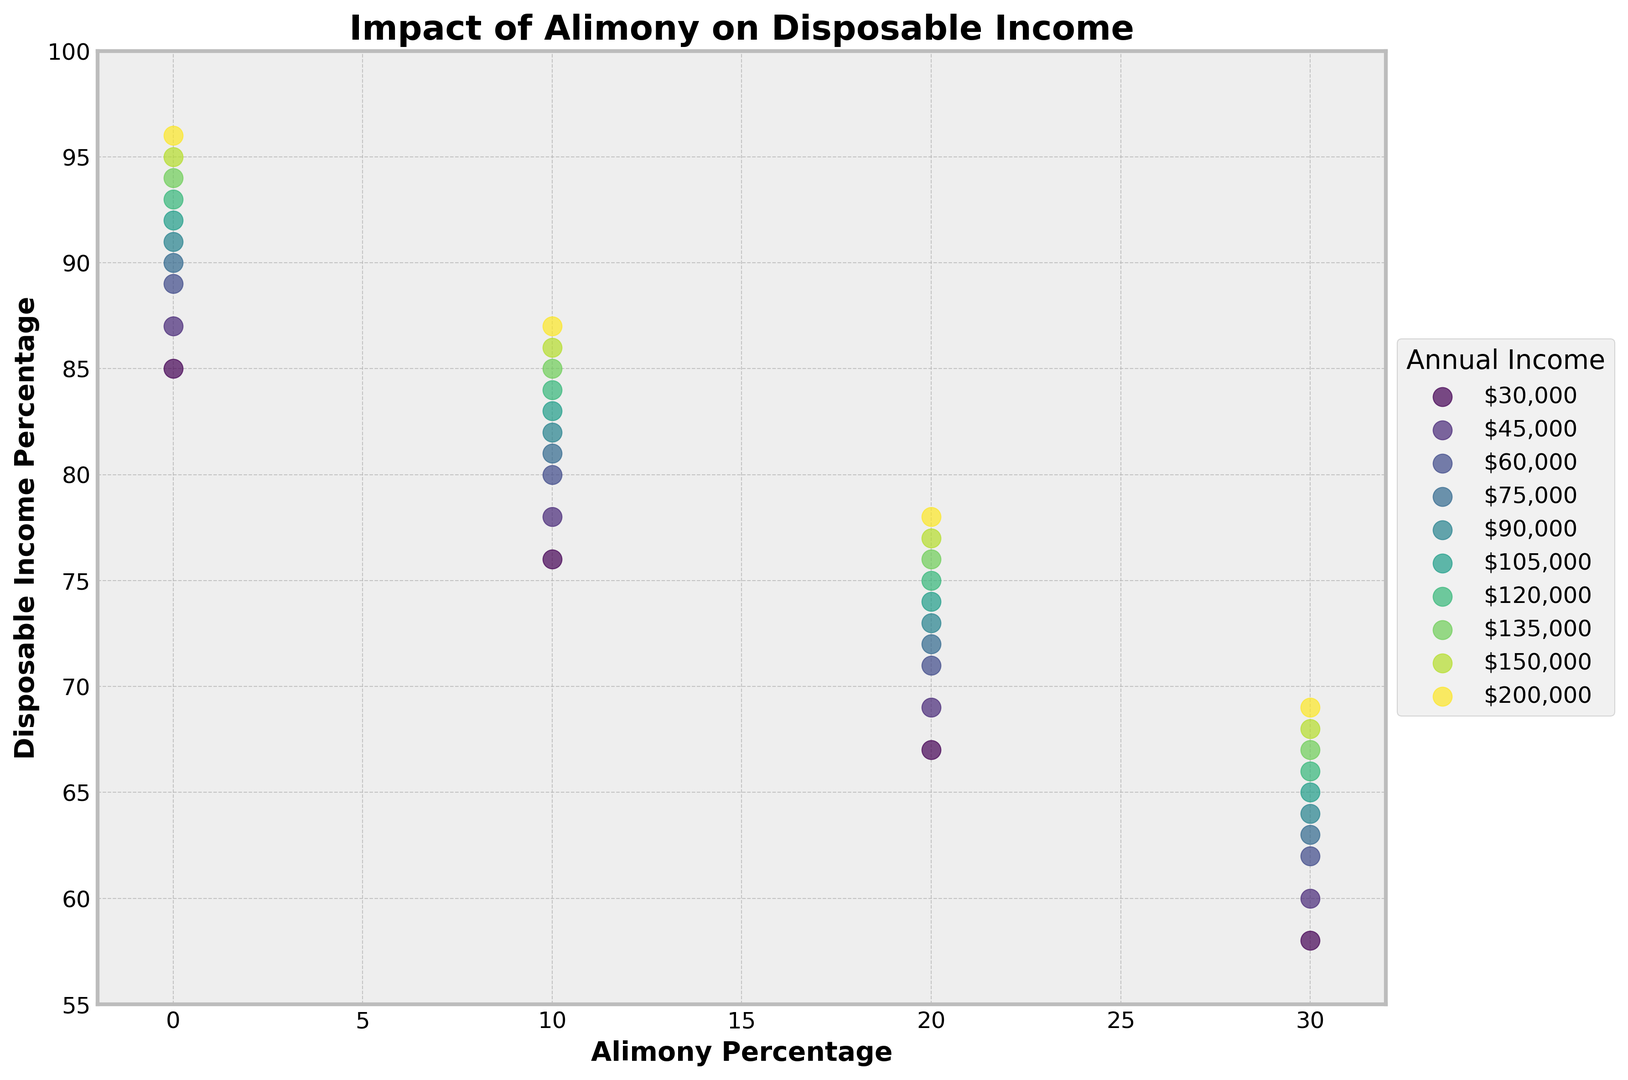How does the disposable income percentage change as the alimony percentage increases for an individual with an annual income of $90,000? By examining the scatter plot, locate the points for an income of $90,000. As the alimony percentage increases from 0% to 30%, the disposable income percentage decreases from 91% to 64%.
Answer: The disposable income percentage decreases from 91% to 64% Which income bracket shows the highest disposable income percentage when no alimony is paid? Look at the scatter plot and identify the highest point at an alimony percentage of 0%. The income bracket of $200,000 shows the highest disposable income percentage of 96%.
Answer: $200,000 Comparing the $30,000 and $150,000 income brackets, how does alimony impact their disposable incomes differently? Analyze the scatter plot points for the $30,000 and $150,000 income brackets. For $30,000, disposable income decreases from 85% to 58%, a drop of 27%. For $150,000, it decreases from 95% to 68%, a drop of 27%. The impact is proportional but not absolute.
Answer: Both drop by 27% For an income of $75,000, what is the difference in disposable income percentage between paying 10% and 20% alimony? Find the points representing $75,000 income. Identify the values at 10% and 20% alimony which are 81% and 72%, respectively. Subtract 72% from 81% to get the difference.
Answer: 9% Which color represents the $45,000 income bracket and what does this color signify about the disposable income trend? On the scatter plot, identify the color used for the $45,000 income bracket. This color, specific to the plot, represents the trend of decreasing disposable income as alimony percentages increase.
Answer: Specific color for $45,000, showing a decreasing trend Among the income brackets displayed, which one has the smallest range in disposable income percentages across the alimony levels? Analyze the scatter plot points for all income brackets. Calculate the range (difference) in disposable income percentages for each bracket. The $200,000 income bracket shows a drop from 96% to 69%, a range of 27%. This is the smallest among the depicted ranges.
Answer: $200,000 with a range of 27% Does every income bracket experience the same proportional drop in disposable income percentage from 0% to 30% alimony? Look at the data points for all income brackets and compare the drop in disposable income percentage from 0% to 30% alimony. Each bracket does indeed show a reduction of disposable income proportionally by 27%.
Answer: Yes, all drop proportionally by 27% What is the visual trend observed for higher income brackets in terms of disposable income? Observing the scatter plot, higher income brackets start with higher disposable income percentages and maintain a consistent proportional drop as alimony percentages rise. This indicates a visual trend of higher starting and ending disposable incomes for higher earners.
Answer: Higher starting and ending disposable incomes 